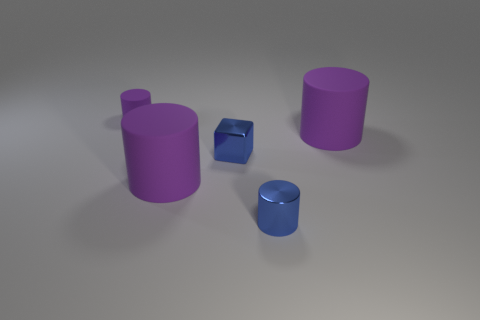There is a small rubber thing; does it have the same color as the cylinder right of the small blue cylinder?
Keep it short and to the point. Yes. There is a large rubber thing left of the metallic block; is its color the same as the tiny matte thing?
Make the answer very short. Yes. Are the small blue cube and the blue cylinder made of the same material?
Provide a succinct answer. Yes. Are there fewer tiny blue things that are behind the block than blue shiny objects that are behind the tiny rubber cylinder?
Provide a short and direct response. No. How many small purple things are behind the blue metallic thing left of the tiny cylinder that is in front of the tiny purple cylinder?
Offer a terse response. 1. Is the metal cube the same color as the small metallic cylinder?
Keep it short and to the point. Yes. Are there any big rubber cylinders that have the same color as the small rubber object?
Offer a very short reply. Yes. What color is the metallic cube that is the same size as the shiny cylinder?
Offer a very short reply. Blue. Are there any large cyan things of the same shape as the tiny matte object?
Ensure brevity in your answer.  No. There is a small metallic thing that is the same color as the cube; what shape is it?
Provide a succinct answer. Cylinder. 